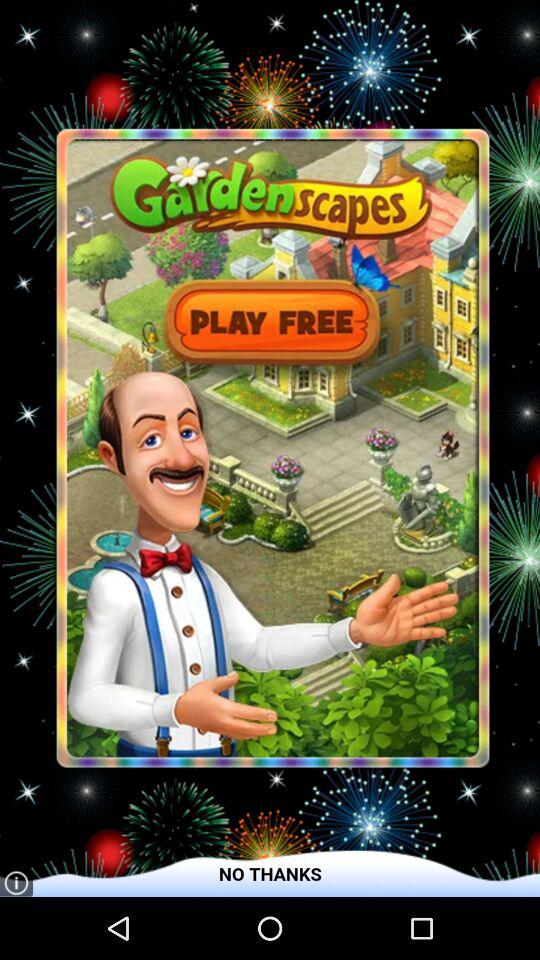What is the name of the application? The name of the application is "Gardenscapes". 